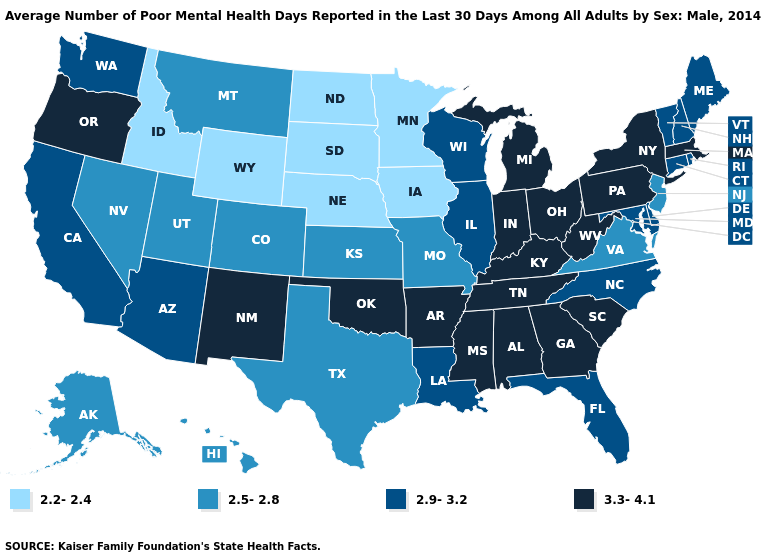What is the value of Wisconsin?
Quick response, please. 2.9-3.2. Is the legend a continuous bar?
Give a very brief answer. No. What is the value of Delaware?
Concise answer only. 2.9-3.2. What is the lowest value in states that border Idaho?
Write a very short answer. 2.2-2.4. Does the map have missing data?
Short answer required. No. Name the states that have a value in the range 2.2-2.4?
Quick response, please. Idaho, Iowa, Minnesota, Nebraska, North Dakota, South Dakota, Wyoming. Does Rhode Island have the lowest value in the Northeast?
Write a very short answer. No. Name the states that have a value in the range 2.9-3.2?
Give a very brief answer. Arizona, California, Connecticut, Delaware, Florida, Illinois, Louisiana, Maine, Maryland, New Hampshire, North Carolina, Rhode Island, Vermont, Washington, Wisconsin. Does Illinois have the same value as Florida?
Concise answer only. Yes. What is the highest value in the South ?
Short answer required. 3.3-4.1. Does Oregon have the highest value in the USA?
Give a very brief answer. Yes. Does New Mexico have the highest value in the West?
Quick response, please. Yes. Name the states that have a value in the range 2.2-2.4?
Concise answer only. Idaho, Iowa, Minnesota, Nebraska, North Dakota, South Dakota, Wyoming. What is the value of Kansas?
Keep it brief. 2.5-2.8. Does the first symbol in the legend represent the smallest category?
Keep it brief. Yes. 